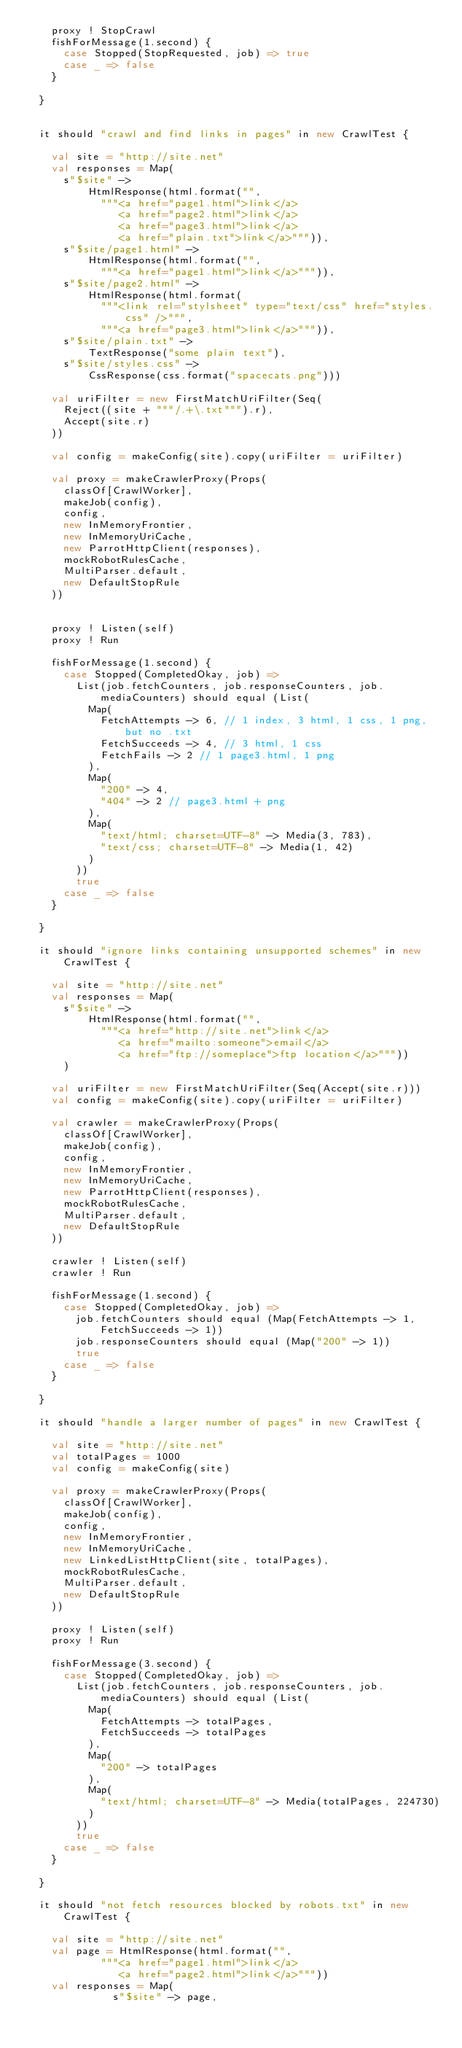<code> <loc_0><loc_0><loc_500><loc_500><_Scala_>    proxy ! StopCrawl
    fishForMessage(1.second) {
      case Stopped(StopRequested, job) => true
      case _ => false
    }

  }


  it should "crawl and find links in pages" in new CrawlTest {
    
    val site = "http://site.net"
    val responses = Map(
      s"$site" -> 
          HtmlResponse(html.format("",
            """<a href="page1.html">link</a>
               <a href="page2.html">link</a>
               <a href="page3.html">link</a>
               <a href="plain.txt">link</a>""")),
      s"$site/page1.html" -> 
          HtmlResponse(html.format("",
            """<a href="page1.html">link</a>""")),
      s"$site/page2.html" -> 
          HtmlResponse(html.format(
            """<link rel="stylsheet" type="text/css" href="styles.css" />""",
            """<a href="page3.html">link</a>""")),
      s"$site/plain.txt" -> 
          TextResponse("some plain text"),
      s"$site/styles.css" -> 
          CssResponse(css.format("spacecats.png")))

    val uriFilter = new FirstMatchUriFilter(Seq(
      Reject((site + """/.+\.txt""").r),
      Accept(site.r)
    ))

    val config = makeConfig(site).copy(uriFilter = uriFilter)

    val proxy = makeCrawlerProxy(Props(
      classOf[CrawlWorker], 
      makeJob(config),
      config,
      new InMemoryFrontier,
      new InMemoryUriCache,
      new ParrotHttpClient(responses),
      mockRobotRulesCache,
      MultiParser.default,
      new DefaultStopRule
    ))


    proxy ! Listen(self)
    proxy ! Run

    fishForMessage(1.second) {
      case Stopped(CompletedOkay, job) => 
        List(job.fetchCounters, job.responseCounters, job.mediaCounters) should equal (List(
          Map(
            FetchAttempts -> 6, // 1 index, 3 html, 1 css, 1 png, but no .txt
            FetchSucceeds -> 4, // 3 html, 1 css
            FetchFails -> 2 // 1 page3.html, 1 png
          ),
          Map(
            "200" -> 4,
            "404" -> 2 // page3.html + png
          ),
          Map(
            "text/html; charset=UTF-8" -> Media(3, 783),
            "text/css; charset=UTF-8" -> Media(1, 42)
          )
        ))
        true
      case _ => false
    }
    
  }

  it should "ignore links containing unsupported schemes" in new CrawlTest {
    
    val site = "http://site.net"
    val responses = Map(
      s"$site" -> 
          HtmlResponse(html.format("",
            """<a href="http://site.net">link</a>
               <a href="mailto:someone">email</a>
               <a href="ftp://someplace">ftp location</a>"""))
      )

    val uriFilter = new FirstMatchUriFilter(Seq(Accept(site.r)))
    val config = makeConfig(site).copy(uriFilter = uriFilter)

    val crawler = makeCrawlerProxy(Props(
      classOf[CrawlWorker], 
      makeJob(config),
      config,
      new InMemoryFrontier,
      new InMemoryUriCache,
      new ParrotHttpClient(responses),
      mockRobotRulesCache,
      MultiParser.default,
      new DefaultStopRule
    ))

    crawler ! Listen(self)
    crawler ! Run

    fishForMessage(1.second) {
      case Stopped(CompletedOkay, job) => 
        job.fetchCounters should equal (Map(FetchAttempts -> 1, FetchSucceeds -> 1))
        job.responseCounters should equal (Map("200" -> 1))
        true
      case _ => false
    }
    
  }

  it should "handle a larger number of pages" in new CrawlTest {

    val site = "http://site.net"
    val totalPages = 1000
    val config = makeConfig(site)

    val proxy = makeCrawlerProxy(Props(
      classOf[CrawlWorker], 
      makeJob(config),
      config,
      new InMemoryFrontier,
      new InMemoryUriCache,
      new LinkedListHttpClient(site, totalPages),
      mockRobotRulesCache,
      MultiParser.default,
      new DefaultStopRule
    ))
    
    proxy ! Listen(self)
    proxy ! Run

    fishForMessage(3.second) {
      case Stopped(CompletedOkay, job) => 
        List(job.fetchCounters, job.responseCounters, job.mediaCounters) should equal (List(
          Map(
            FetchAttempts -> totalPages,
            FetchSucceeds -> totalPages
          ),
          Map(
            "200" -> totalPages
          ),
          Map(
            "text/html; charset=UTF-8" -> Media(totalPages, 224730)
          )
        ))
        true
      case _ => false
    }

  }

  it should "not fetch resources blocked by robots.txt" in new CrawlTest {

    val site = "http://site.net"
    val page = HtmlResponse(html.format("",
            """<a href="page1.html">link</a>
               <a href="page2.html">link</a>"""))
    val responses = Map(
              s"$site" -> page,</code> 